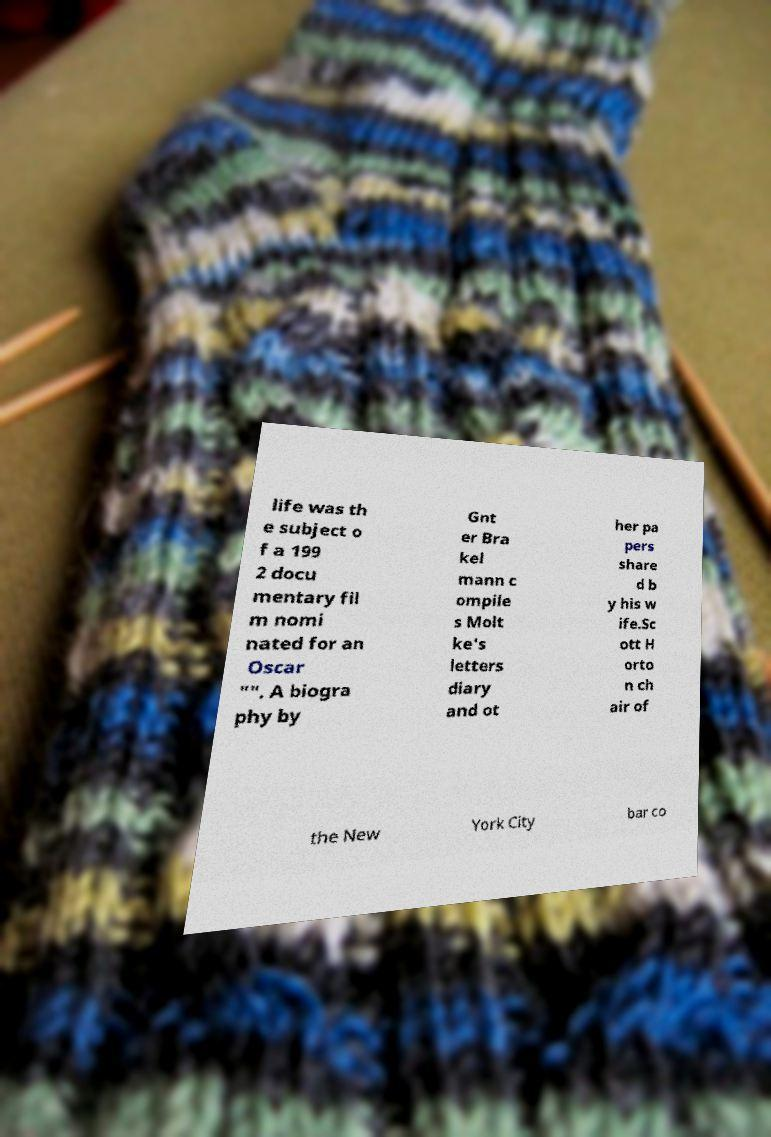Can you read and provide the text displayed in the image?This photo seems to have some interesting text. Can you extract and type it out for me? life was th e subject o f a 199 2 docu mentary fil m nomi nated for an Oscar "". A biogra phy by Gnt er Bra kel mann c ompile s Molt ke's letters diary and ot her pa pers share d b y his w ife.Sc ott H orto n ch air of the New York City bar co 